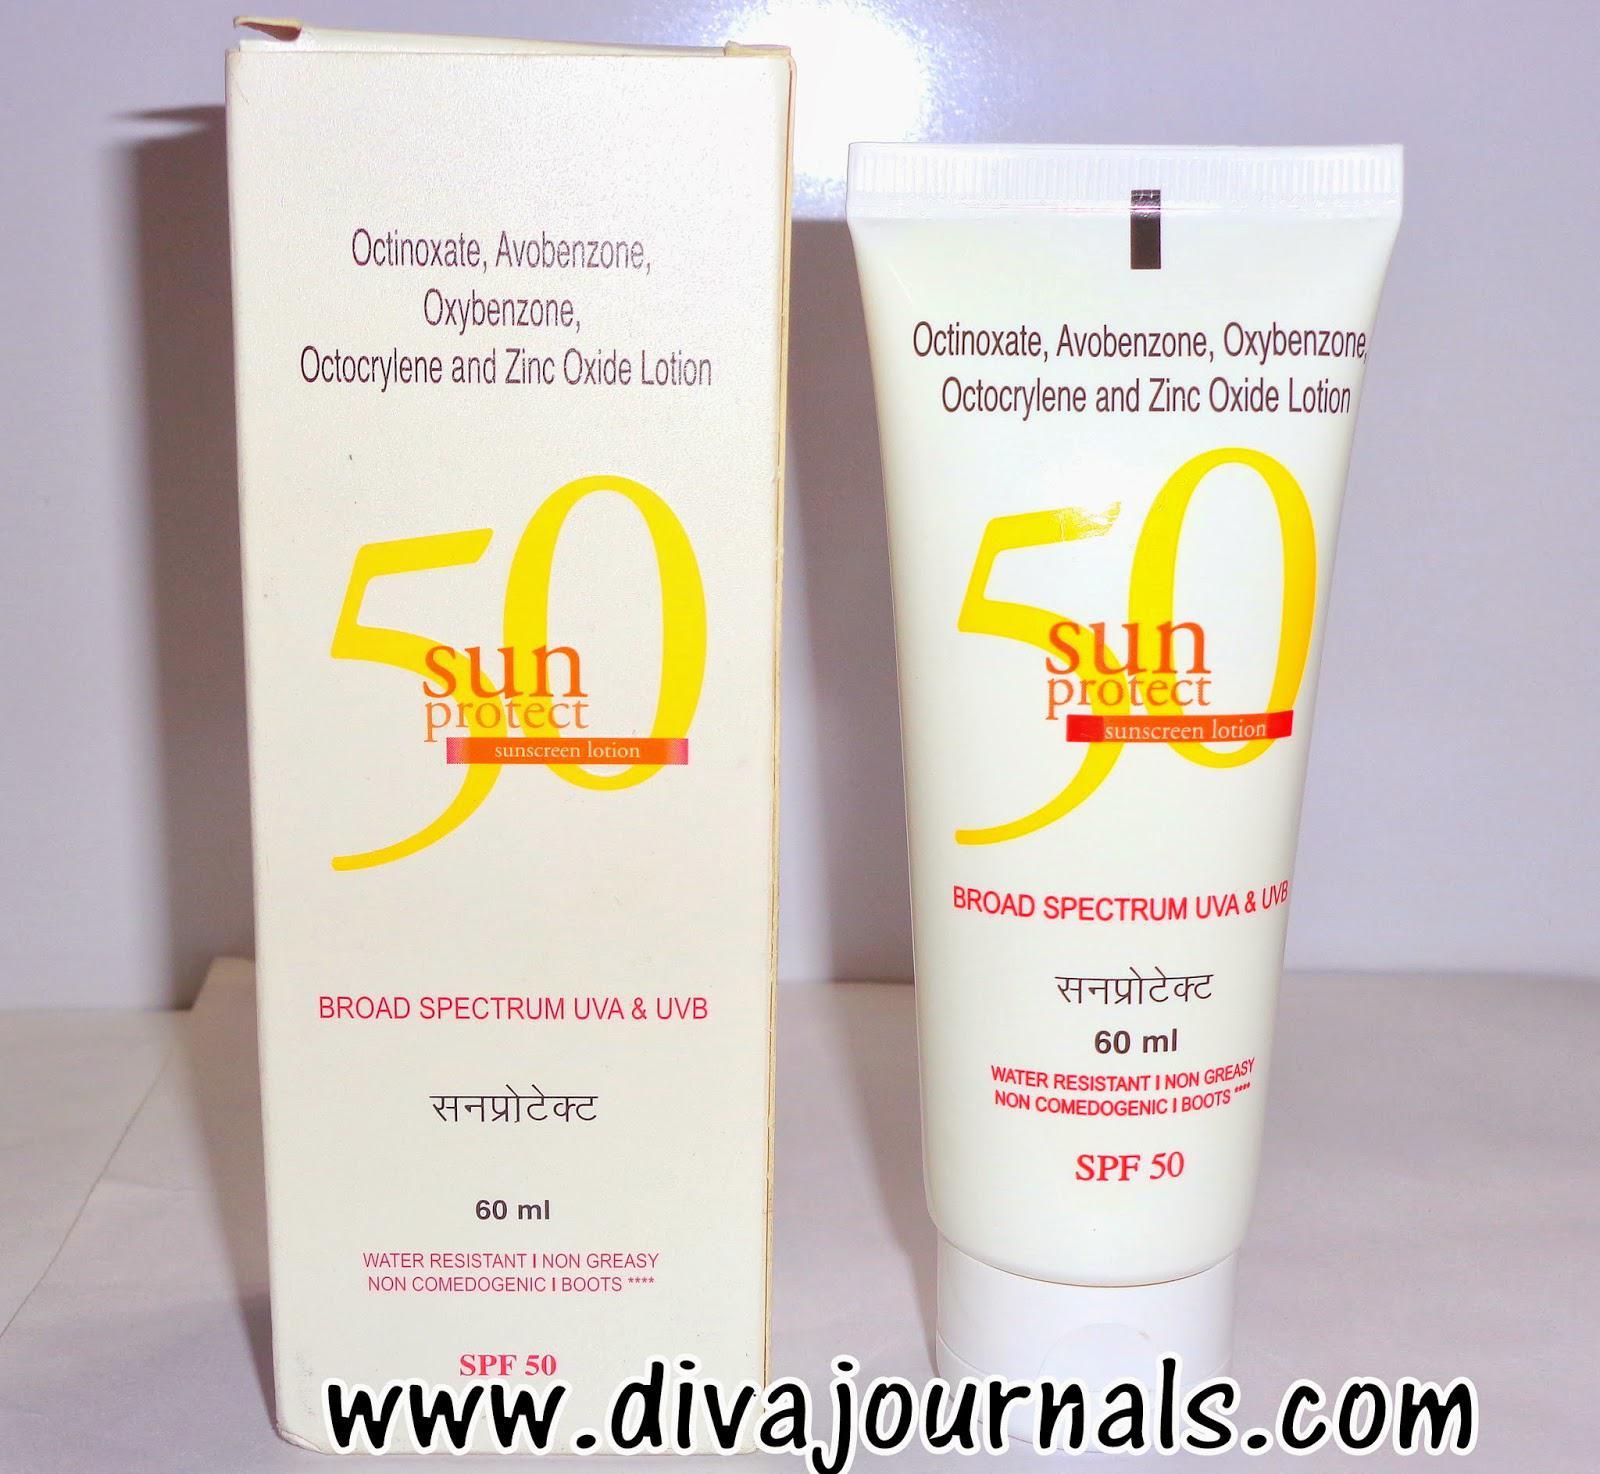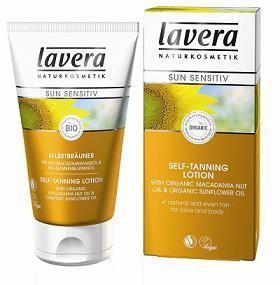The first image is the image on the left, the second image is the image on the right. Considering the images on both sides, is "Each image shows one skincare product next to its box." valid? Answer yes or no. Yes. 